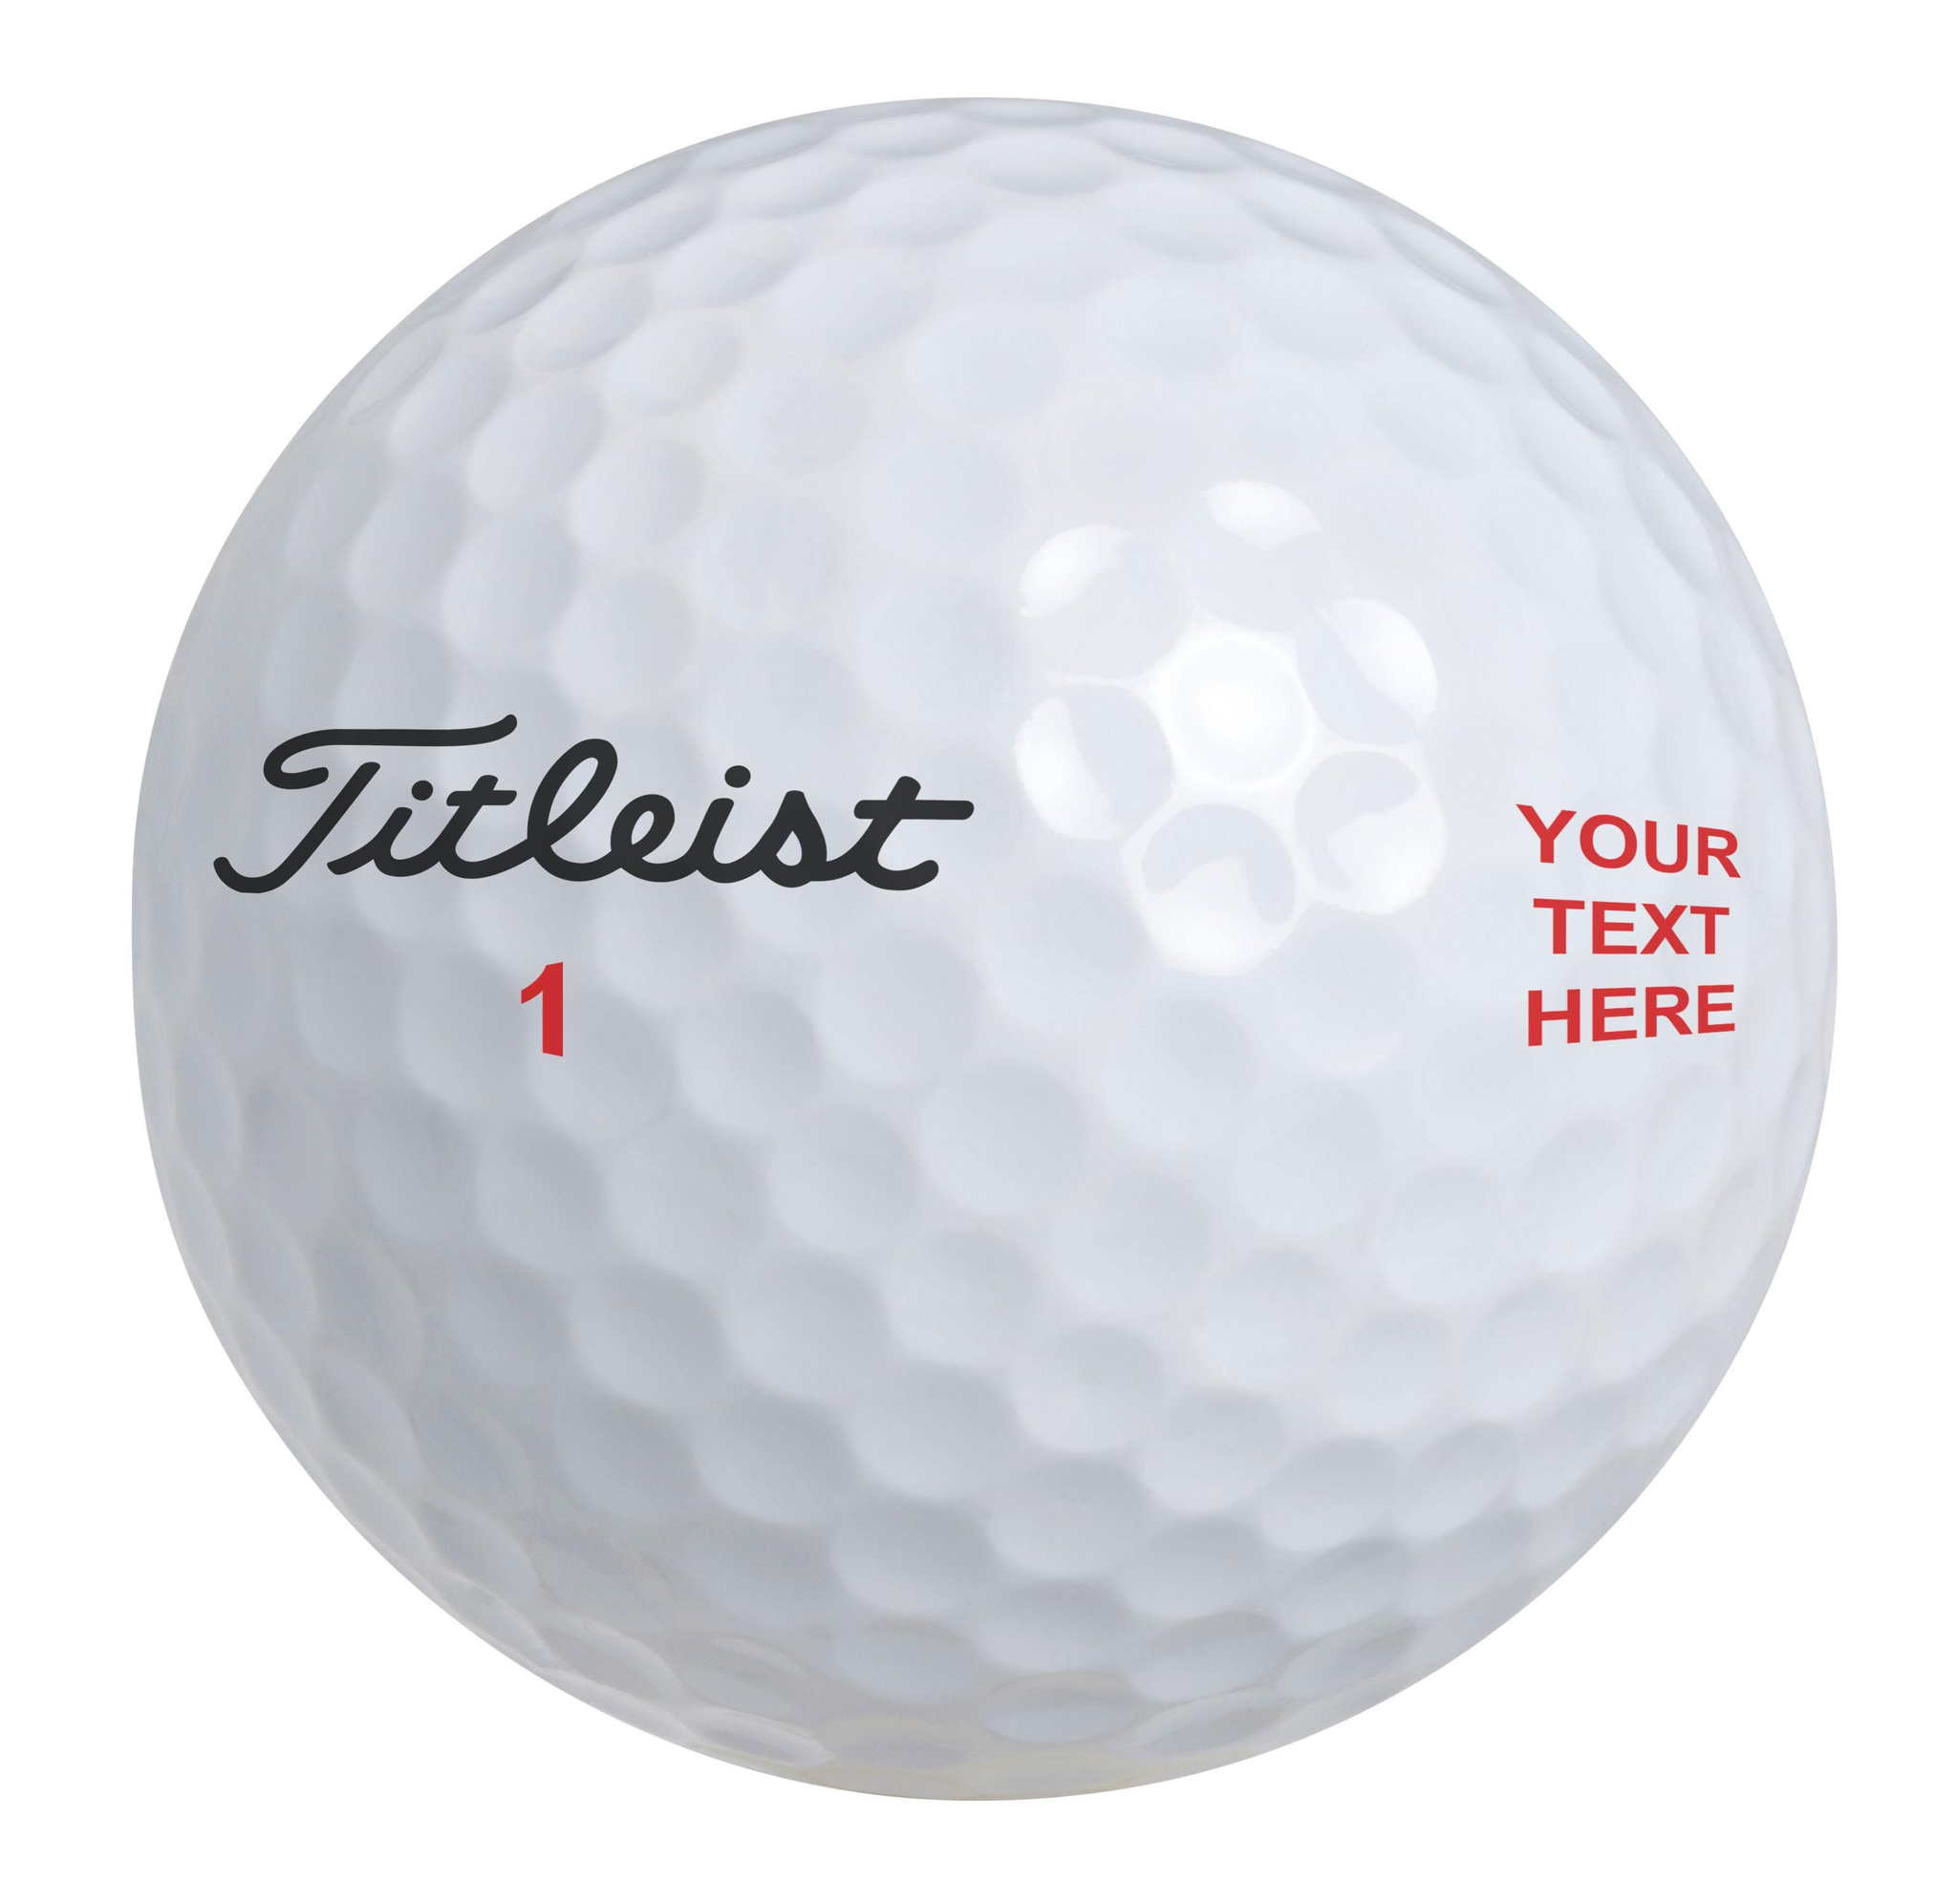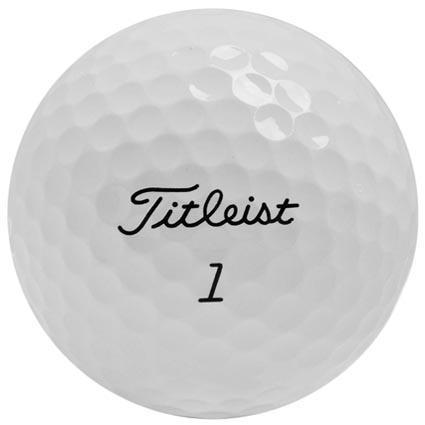The first image is the image on the left, the second image is the image on the right. For the images shown, is this caption "A golf ball is near a black golf club" true? Answer yes or no. No. 